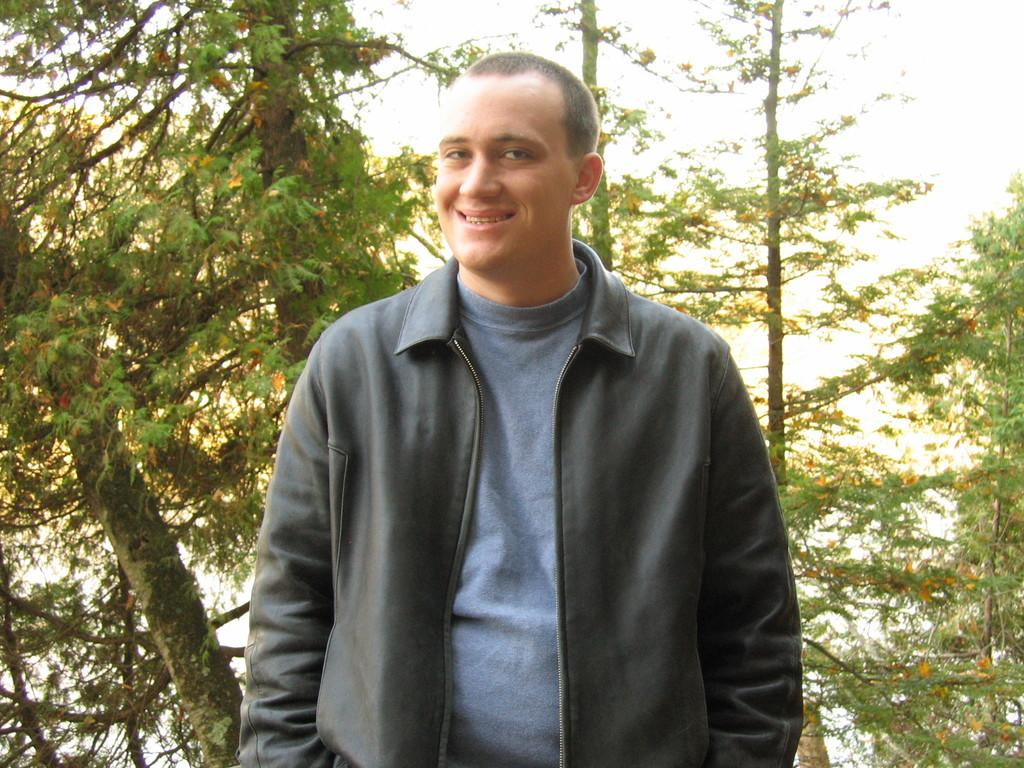Who is in the image? There is a man in the image. What is the man wearing? The man is wearing a jacket. What is the man's facial expression? The man is smiling. What is the man doing in the image? The man is posing for the picture. What can be seen in the background of the image? There are many trees in the background of the image. What type of fang can be seen in the man's mouth in the image? There is no fang visible in the man's mouth in the image. What is the texture of the man's jacket in the image? The provided facts do not mention the texture of the man's jacket, so it cannot be determined from the image. 